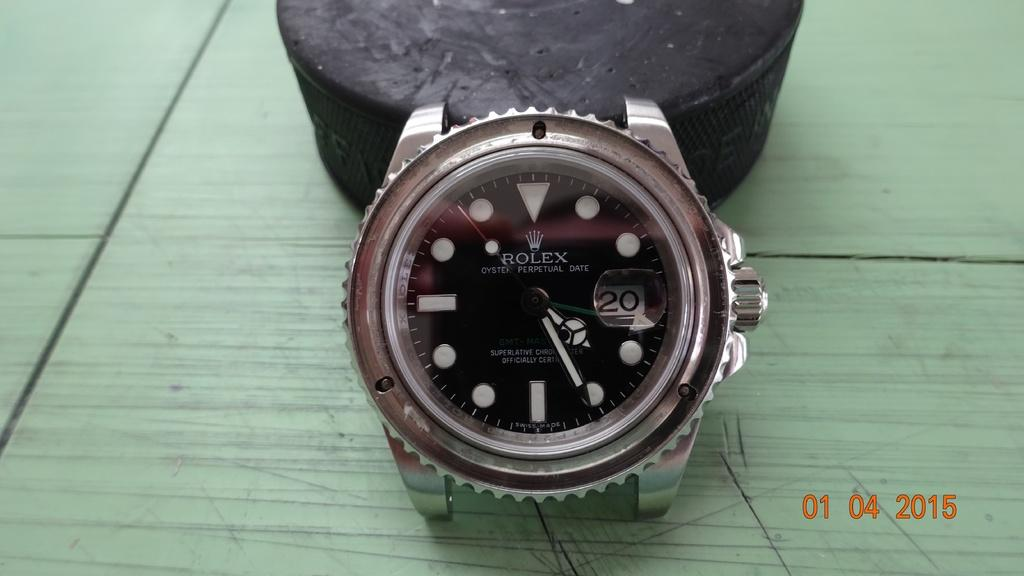What object can be seen in the image? There is a watch in the image. Where is the watch located? The watch is on a platform. What type of skirt is draped over the watch on the platform? There is no skirt present in the image; it only features a watch on a platform. 